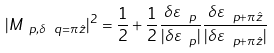<formula> <loc_0><loc_0><loc_500><loc_500>| M _ { \ p , \delta \ q = \pi \hat { z } } | ^ { 2 } = \frac { 1 } { 2 } + \frac { 1 } { 2 } \frac { \delta \varepsilon _ { \ p } } { | \delta \varepsilon _ { \ p } | } \frac { \delta \varepsilon _ { \ p + \pi \hat { z } } } { | \delta \varepsilon _ { \ p + \pi \hat { z } } | }</formula> 